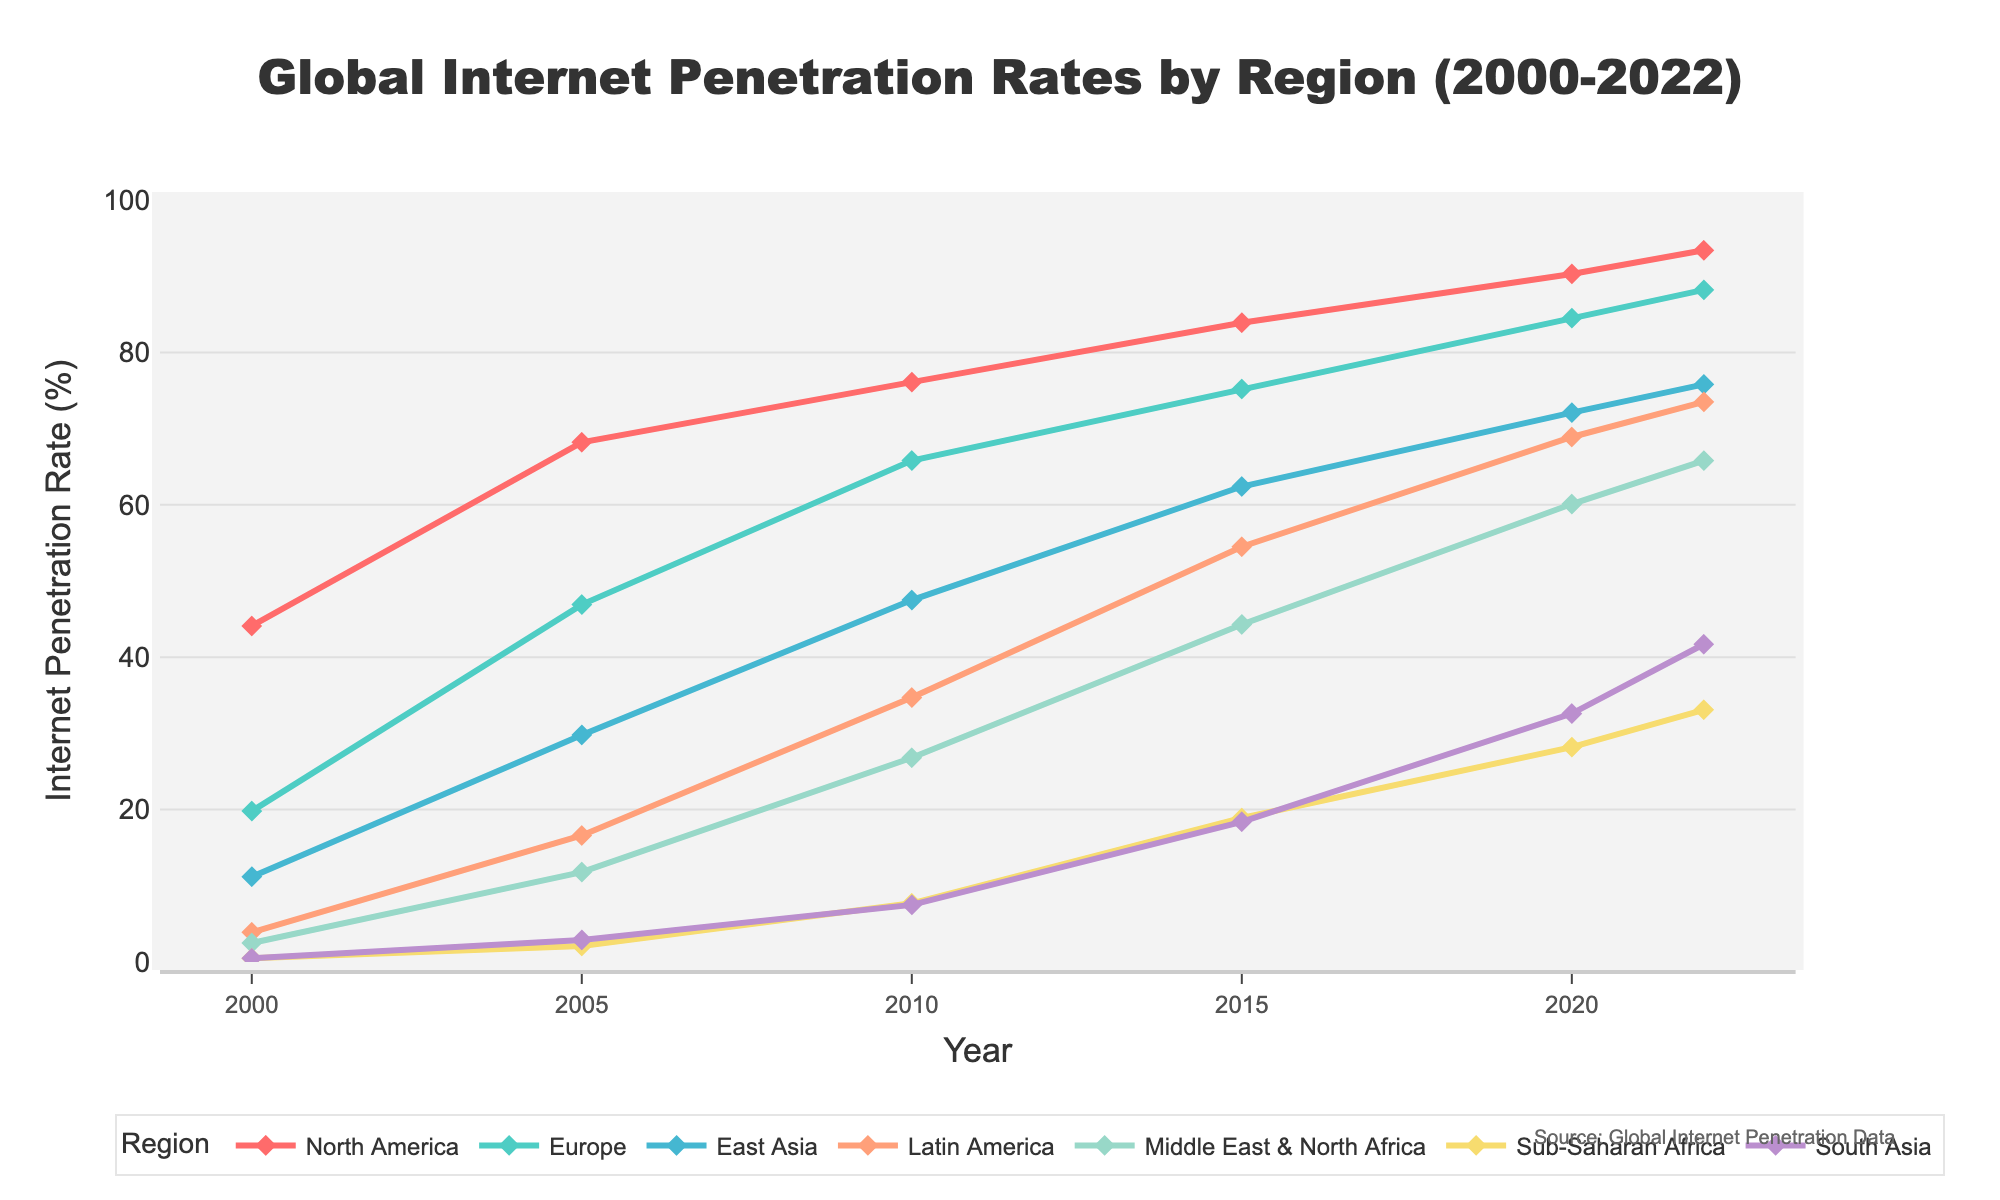What was the internet penetration rate in South Asia in 2022? According to the chart, the internet penetration rate in South Asia can be found by looking at the data point for the year 2022 on the South Asia line.
Answer: 41.7% How much did the internet penetration rate in Sub-Saharan Africa increase from 2000 to 2022? In 2000, the penetration rate in Sub-Saharan Africa was 0.5%. By 2022, it had increased to 33.1%. Subtracting the 2000 rate from the 2022 rate gives the total increase. 33.1% - 0.5% = 32.6%
Answer: 32.6% Which region had the highest internet penetration rate in 2020? By observing the heights of the lines at the 2020 mark, North America has the highest internet penetration rate compared to other regions.
Answer: North America How does the internet penetration rate in East Asia in 2022 compare to that in Latin America in 2020? From the chart, the rate for East Asia in 2022 is 75.8%, and for Latin America in 2020, it is 68.9%. Comparing these, 75.8% is greater than 68.9%.
Answer: East Asia had a higher rate What is the average internet penetration rate of Europe between 2000 and 2022? To find the average, sum the internet penetration rates for Europe from 2000 to 2022 and divide by the number of years: (19.8 + 46.9 + 65.8 + 75.2 + 84.5 + 88.2) / 6 = 63.4%
Answer: 63.4% Between 2010 and 2022, which region saw the greatest increase in internet penetration rate? Calculate the increase for each region by subtracting the 2010 rate from the 2022 rate and find the highest value among: North America (93.4-76.1), Europe (88.2-65.8), East Asia (75.8-47.5), Latin America (73.5-34.7), Middle East & North Africa (65.8-26.8), Sub-Saharan Africa (33.1-7.7), South Asia (41.7-7.5). Middle East & North Africa has the greatest increase of 39%.
Answer: Middle East & North Africa Which regions had an internet penetration rate of below 50% in 2020, and what were those rates? Check the 2020 data points and identify the regions with rates below 50% which are Sub-Saharan Africa (28.2%) and South Asia (32.6%).
Answer: Sub-Saharan Africa (28.2%), South Asia (32.6%) By what percentage did the internet penetration rate in Latin America increase from 2015 to 2020? Determine the rate in 2015 and 2020, then calculate the percentage increase: ((68.9 - 54.5) / 54.5) * 100 = 26.3%.
Answer: 26.3% What is the trend of the internet penetration rate in North America from 2000 to 2022?, Look at the line for North America from 2000 to 2022; it shows a consistent upward trend indicating a steady increase over time.
Answer: Steadily increasing Which region had the least growth in internet penetration from 2010 to 2022? Calculate the growth for each region and find the smallest value: North America (93.4-76.1), Europe (88.2-65.8), East Asia (75.8-47.5), Latin America (73.5-34.7), Middle East & North Africa (65.8-26.8), Sub-Saharan Africa (33.1-7.7), South Asia (41.7-7.5). North America had the least growth of 17.3%.
Answer: North America 